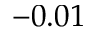Convert formula to latex. <formula><loc_0><loc_0><loc_500><loc_500>- 0 . 0 1</formula> 